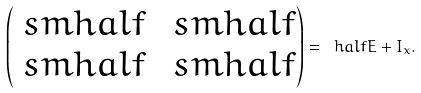Convert formula to latex. <formula><loc_0><loc_0><loc_500><loc_500>\begin{pmatrix} \ s m h a l f & \ s m h a l f \\ \ s m h a l f & \ s m h a l f \end{pmatrix} = \ h a l f E + I _ { x } .</formula> 